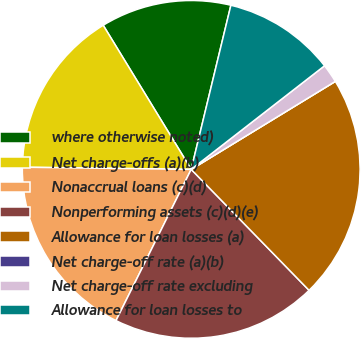Convert chart. <chart><loc_0><loc_0><loc_500><loc_500><pie_chart><fcel>where otherwise noted)<fcel>Net charge-offs (a)(b)<fcel>Nonaccrual loans (c)(d)<fcel>Nonperforming assets (c)(d)(e)<fcel>Allowance for loan losses (a)<fcel>Net charge-off rate (a)(b)<fcel>Net charge-off rate excluding<fcel>Allowance for loan losses to<nl><fcel>12.5%<fcel>16.07%<fcel>17.86%<fcel>19.64%<fcel>21.43%<fcel>0.0%<fcel>1.79%<fcel>10.71%<nl></chart> 